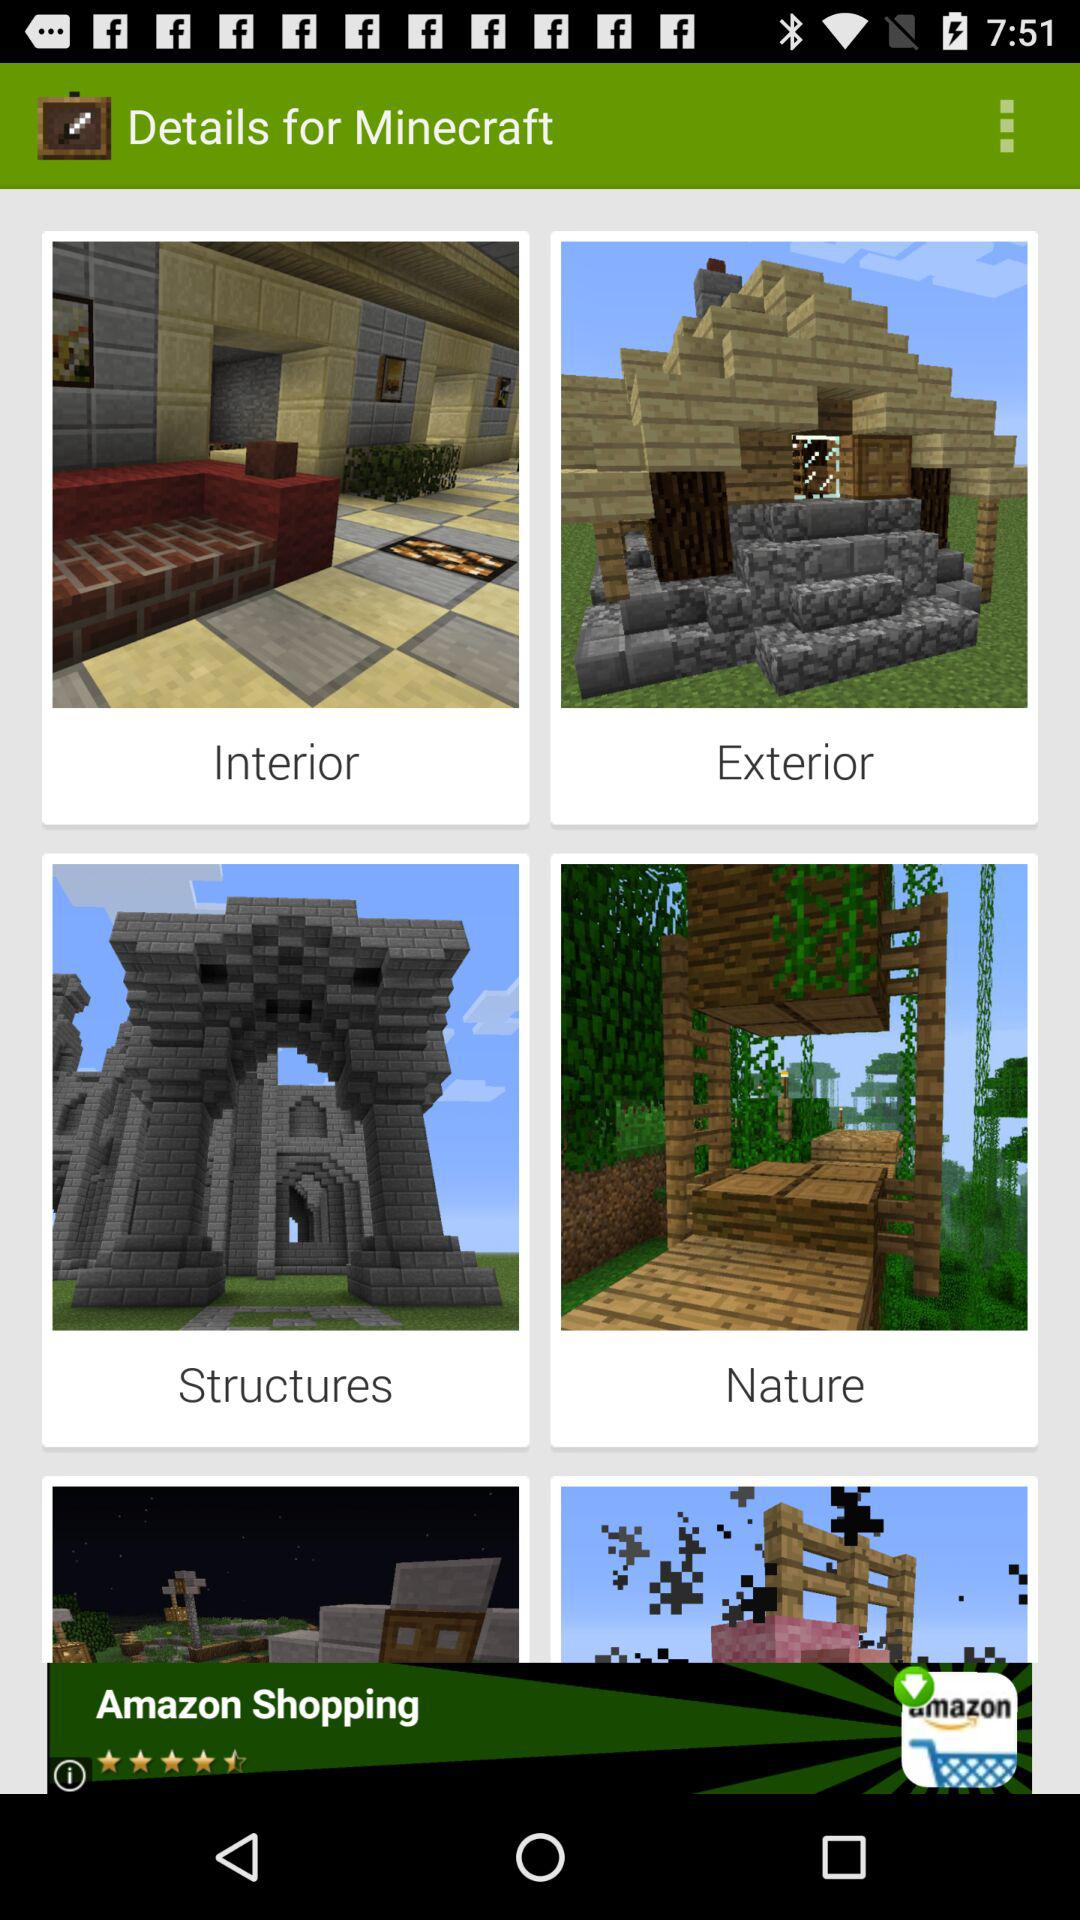Which are the different categories in "Details for Minecraft"? The different categories in "Details for Minecraft" are "Interior", "Exterior", "Structures" and "Nature". 